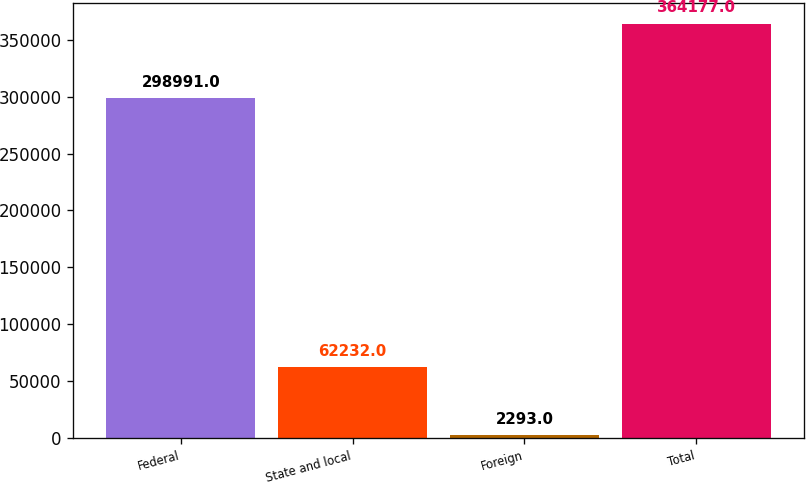Convert chart to OTSL. <chart><loc_0><loc_0><loc_500><loc_500><bar_chart><fcel>Federal<fcel>State and local<fcel>Foreign<fcel>Total<nl><fcel>298991<fcel>62232<fcel>2293<fcel>364177<nl></chart> 